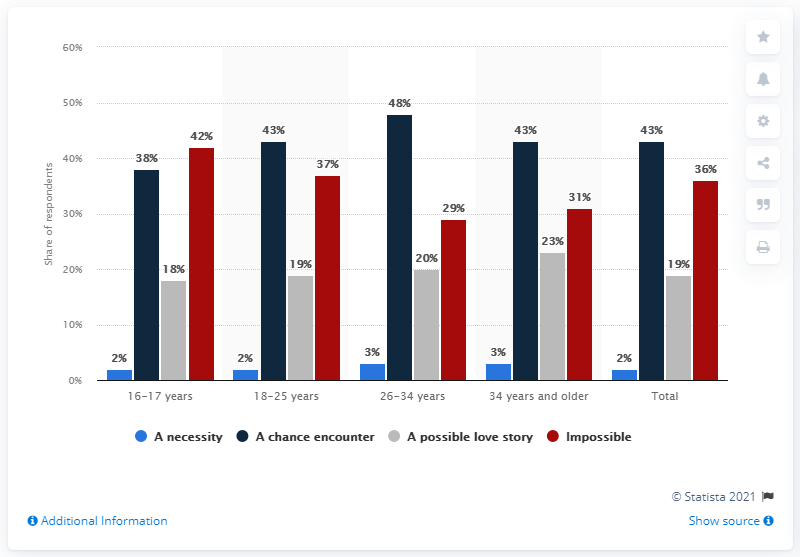Draw attention to some important aspects in this diagram. The average of necessity is 2.4. The color red represents something that is impossible to achieve. 